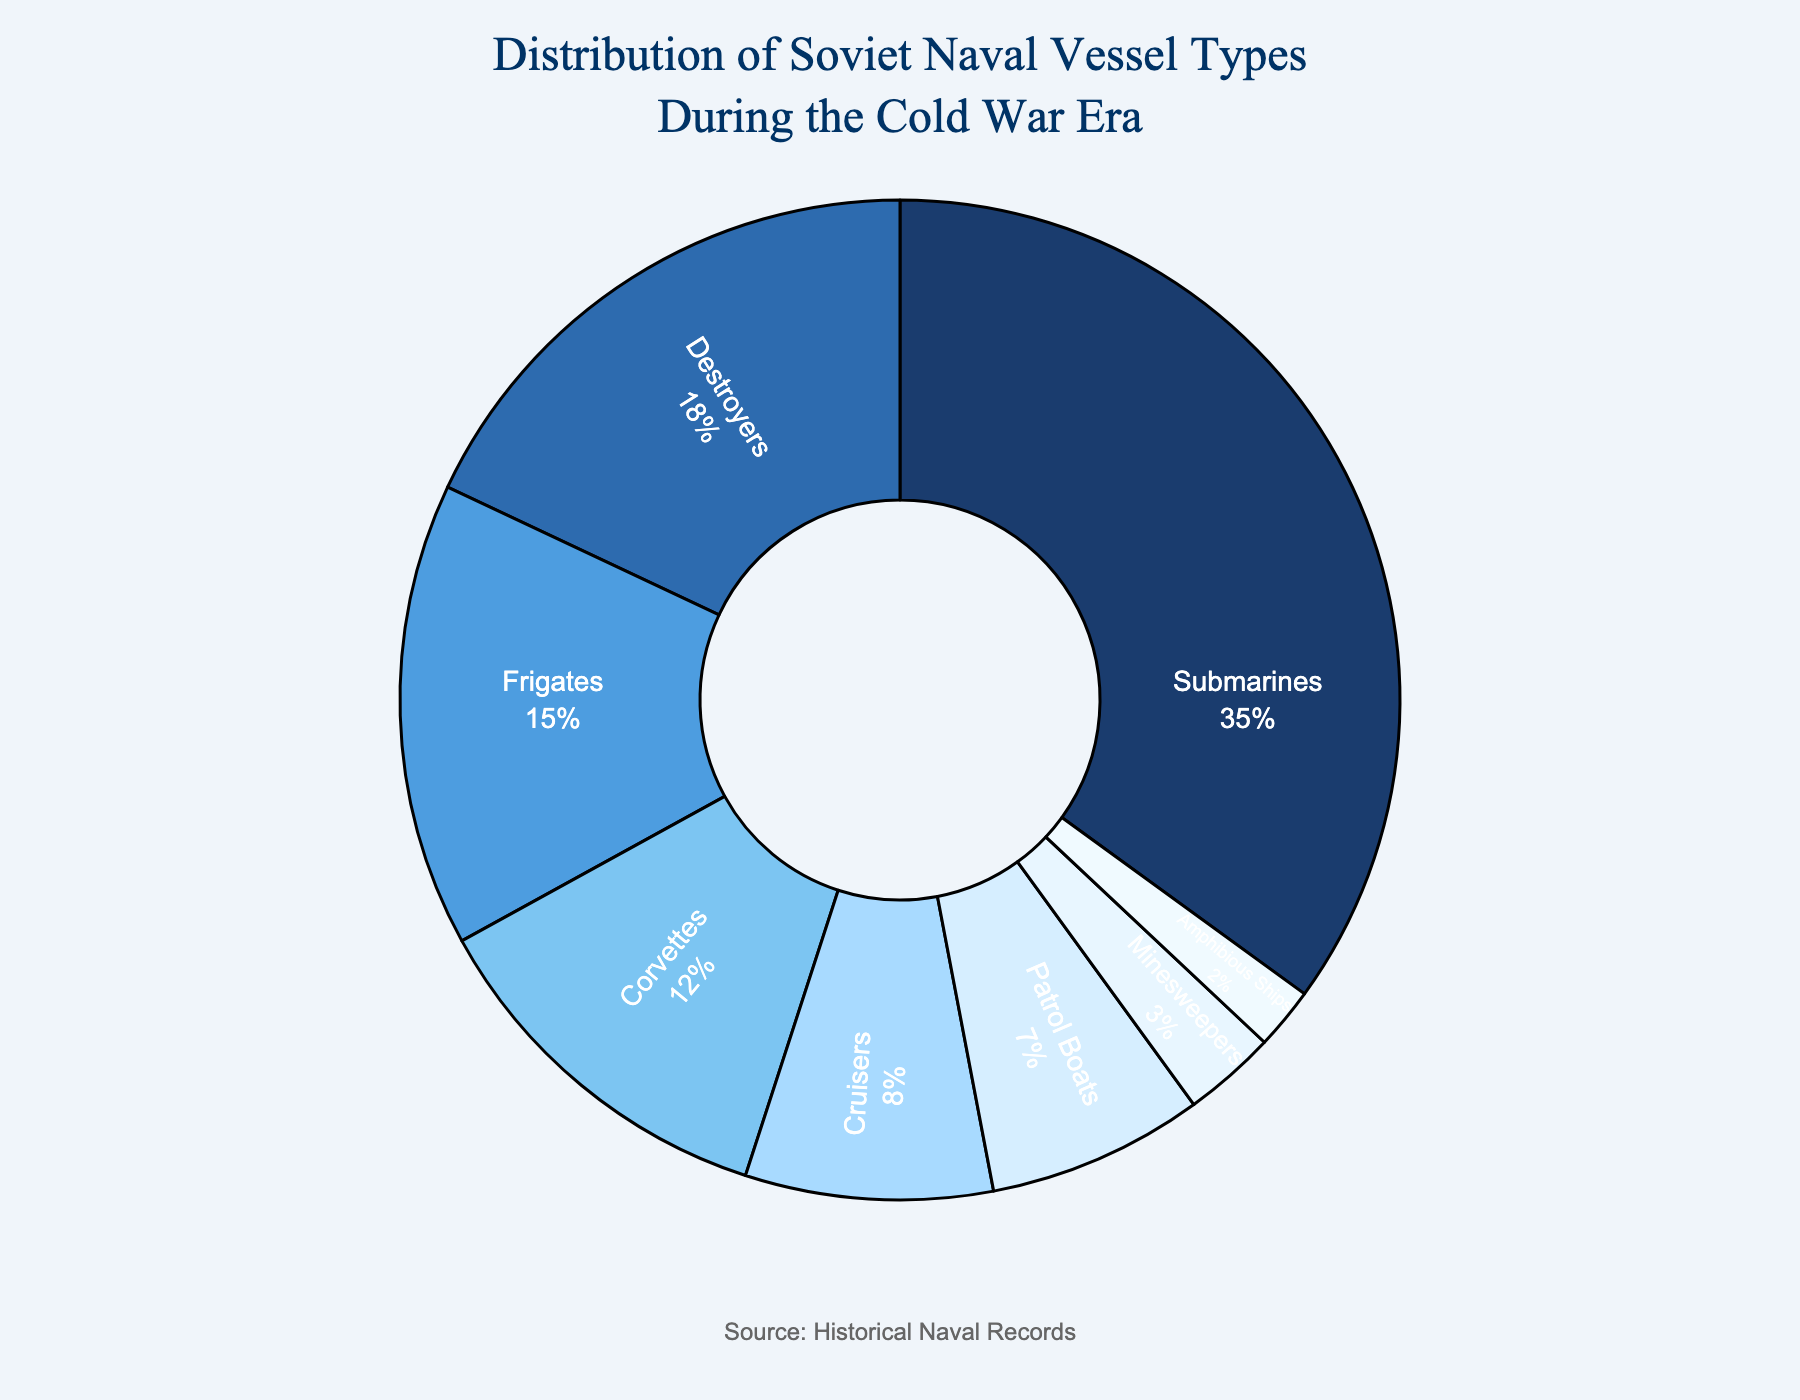Which vessel type has the highest percentage representation in the Soviet naval distribution? By examining the pie chart, we see that submarines occupy the largest section of the chart, meaning they have the highest percentage.
Answer: Submarines What percentage of the total naval vessels do cruisers and corvettes together account for? The percentage for cruisers is 8% and for corvettes is 12%. Adding these two together gives 8% + 12% = 20%.
Answer: 20% Which vessel types have a lower percentage representation than destroyers but higher than patrol boats? Destroyers have a representation of 18%, while patrol boats have 7%. The vessel types within this range are frigates (15%), corvettes (12%), and cruisers (8%).
Answer: Frigates, Corvettes, Cruisers How many vessel types account for at least 10% of the total naval vessels each? The vessel types with at least 10% are submarines (35%), destroyers (18%), frigates (15%), and corvettes (12%). Counting these, there are four vessel types.
Answer: 4 What is the combined percentage of patrol boats and minesweepers? The percentage for patrol boats is 7% and for minesweepers is 3%. Adding these two together gives 7% + 3% = 10%.
Answer: 10% Do corvettes have a higher or lower percentage than frigates? By looking at the pie chart, corvettes have 12%, while frigates have 15%. Comparing these, corvettes have a lower percentage.
Answer: Lower What is the difference in percentage between minesweepers and amphibious ships? Minesweepers account for 3% while amphibious ships account for 2%. The difference in their percentages is 3% - 2% = 1%.
Answer: 1% Which vessel type has the smallest percentage share? The smallest percentage share in the chart is represented by amphibious ships, which have a percentage of 2%.
Answer: Amphibious Ships What is the percentage range of all vessel types represented in the chart? The highest percentage is for submarines at 35%, and the lowest is for amphibious ships at 2%. Therefore, the range is 35% - 2% = 33%.
Answer: 33% Are there more vessel types with a percentage greater than or equal to 15%, or less than 10%? The vessel types with percentages greater than or equal to 15% are submarines (35%), destroyers (18%), and frigates (15%) totaling 3 types. The vessel types with percentages less than 10% are cruisers (8%), patrol boats (7%), minesweepers (3%), and amphibious ships (2%) totaling 4 types. Comparing these, there are more vessel types with percentages less than 10%.
Answer: Less than 10% 